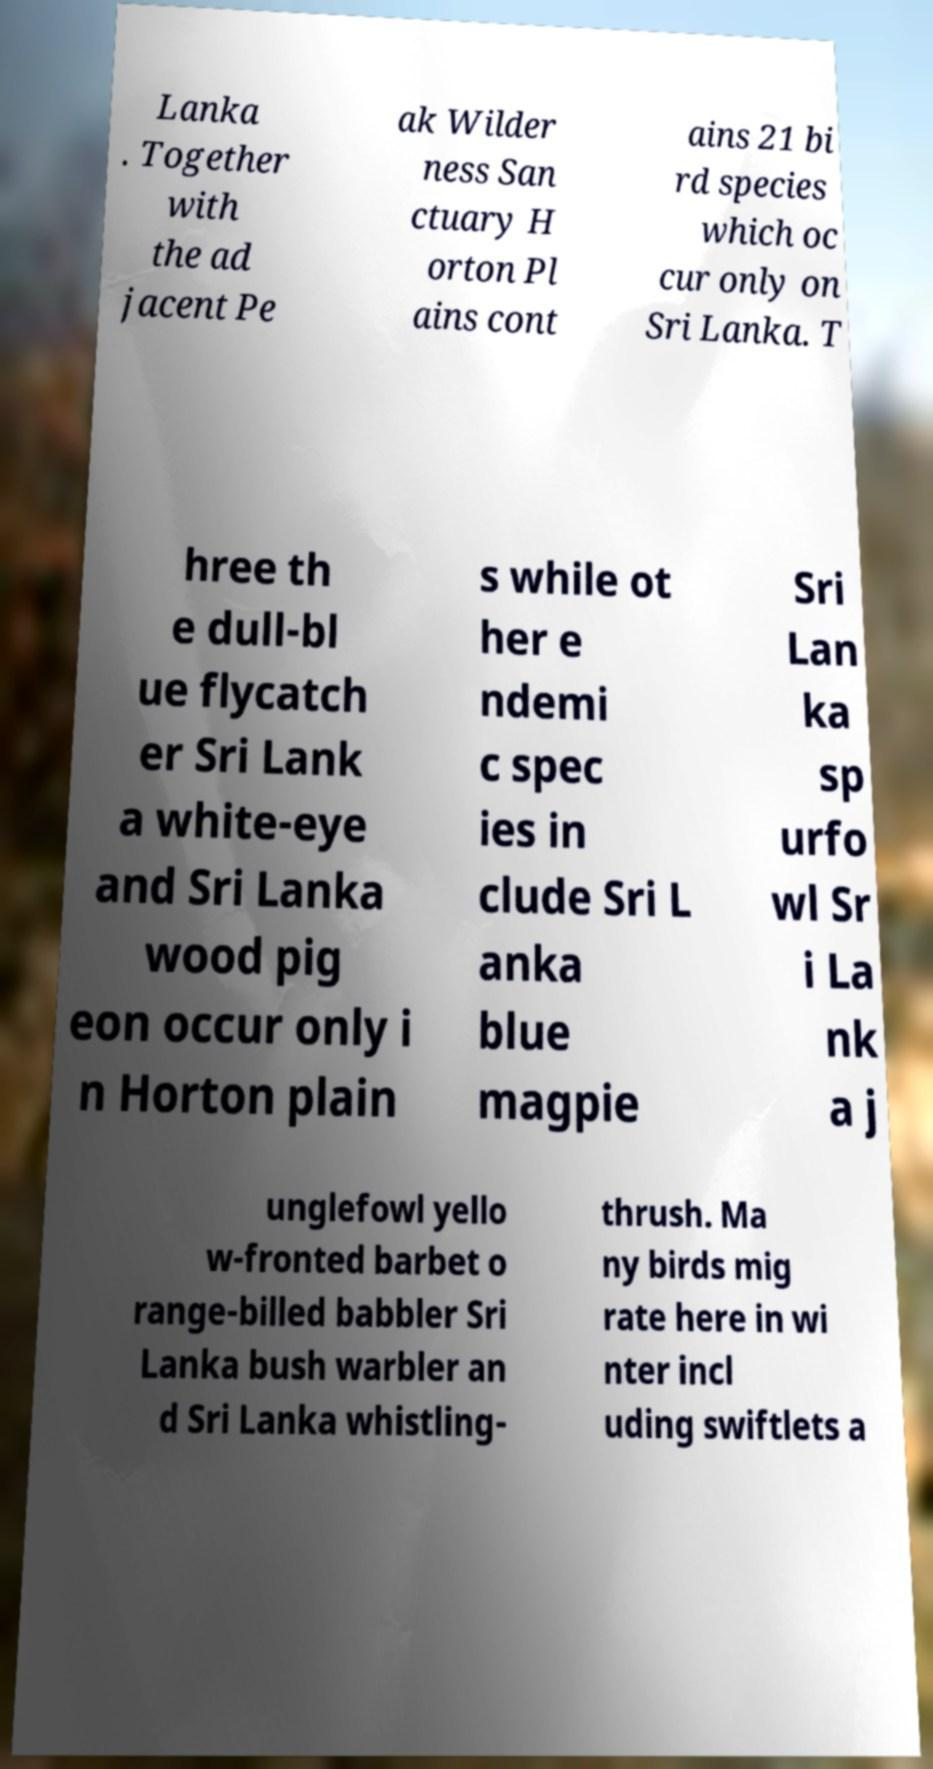Could you assist in decoding the text presented in this image and type it out clearly? Lanka . Together with the ad jacent Pe ak Wilder ness San ctuary H orton Pl ains cont ains 21 bi rd species which oc cur only on Sri Lanka. T hree th e dull-bl ue flycatch er Sri Lank a white-eye and Sri Lanka wood pig eon occur only i n Horton plain s while ot her e ndemi c spec ies in clude Sri L anka blue magpie Sri Lan ka sp urfo wl Sr i La nk a j unglefowl yello w-fronted barbet o range-billed babbler Sri Lanka bush warbler an d Sri Lanka whistling- thrush. Ma ny birds mig rate here in wi nter incl uding swiftlets a 